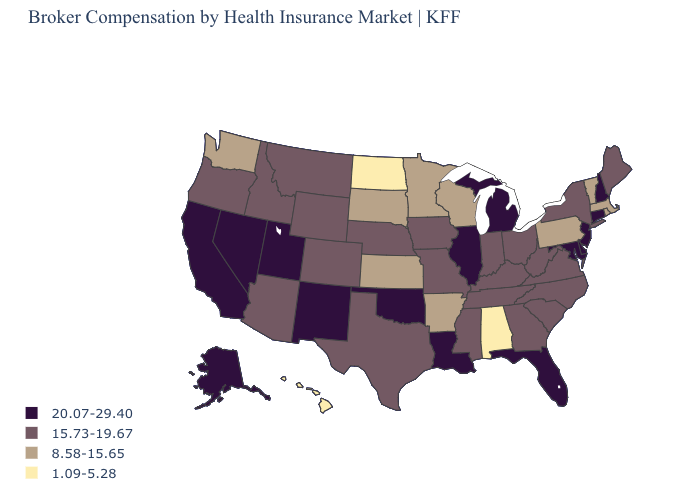Which states have the lowest value in the Northeast?
Be succinct. Massachusetts, Pennsylvania, Rhode Island, Vermont. Does the first symbol in the legend represent the smallest category?
Keep it brief. No. What is the value of Missouri?
Write a very short answer. 15.73-19.67. What is the value of Nebraska?
Concise answer only. 15.73-19.67. What is the lowest value in the Northeast?
Quick response, please. 8.58-15.65. What is the value of Iowa?
Give a very brief answer. 15.73-19.67. Among the states that border Utah , does Nevada have the highest value?
Be succinct. Yes. What is the value of Oregon?
Answer briefly. 15.73-19.67. Which states hav the highest value in the Northeast?
Short answer required. Connecticut, New Hampshire, New Jersey. Name the states that have a value in the range 1.09-5.28?
Quick response, please. Alabama, Hawaii, North Dakota. Does Connecticut have the highest value in the Northeast?
Quick response, please. Yes. What is the value of Arkansas?
Quick response, please. 8.58-15.65. Which states have the lowest value in the MidWest?
Write a very short answer. North Dakota. What is the value of Oregon?
Keep it brief. 15.73-19.67. Does Wyoming have the highest value in the USA?
Write a very short answer. No. 